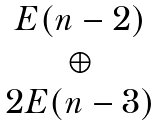Convert formula to latex. <formula><loc_0><loc_0><loc_500><loc_500>\begin{matrix} E ( n - 2 ) \\ \oplus \\ 2 E ( n - 3 ) \end{matrix}</formula> 